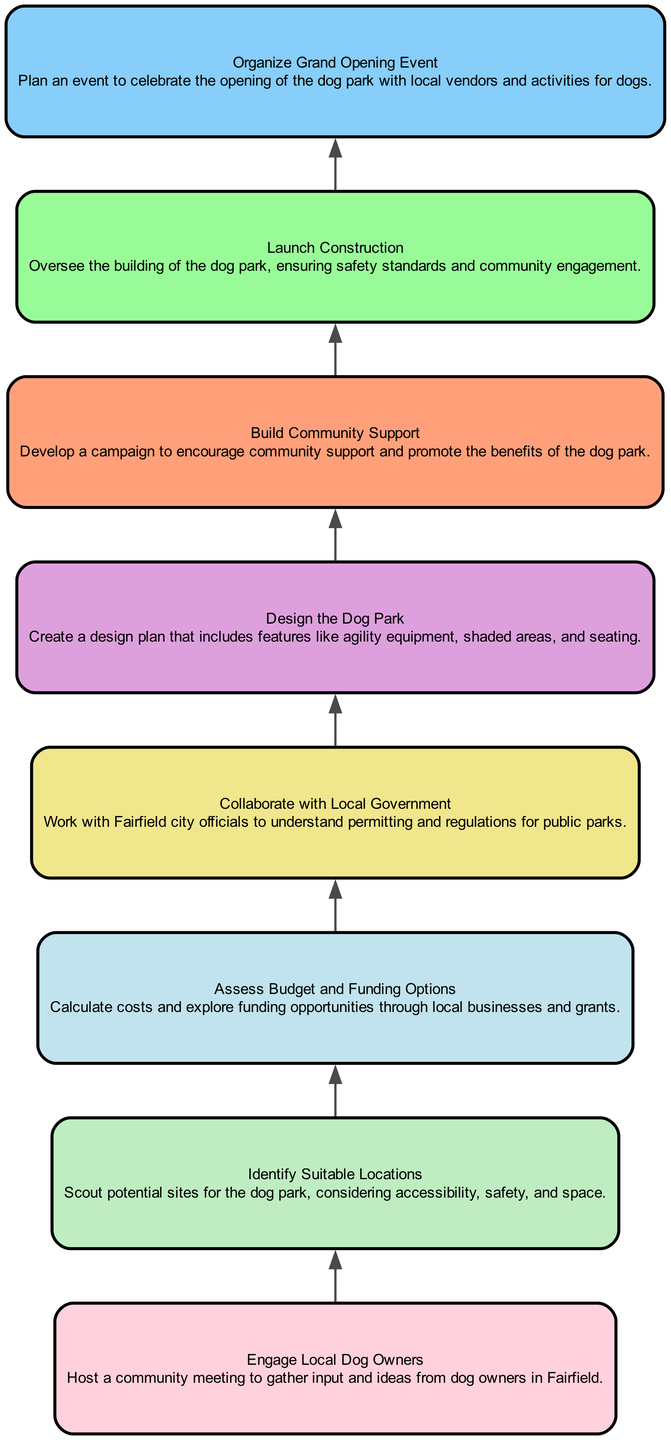What is the first step in the dog park planning process? The first step is labeled as "Engage Local Dog Owners." It is the initial node in the diagram and signifies the starting point of the planning process.
Answer: Engage Local Dog Owners How many total steps are there in the diagram? By counting the number of nodes in the diagram, there are eight distinct steps outlined for planning the dog park.
Answer: 8 What step comes immediately after "Assess Budget and Funding Options"? The step that follows "Assess Budget and Funding Options" is "Collaborate with Local Government." This relationship can be observed directly by looking at the arrows connecting these nodes.
Answer: Collaborate with Local Government Which step focuses on community engagement? The step dedicated to community engagement is "Build Community Support." It explicitly mentions developing a campaign to encourage community support, highlighting its importance in the planning process.
Answer: Build Community Support Which two steps are directly connected to "Design the Dog Park"? "Collaborate with Local Government" precedes it and "Launch Construction" follows it, thus these two steps are connected directly to "Design the Dog Park" in terms of the flow of the planning process.
Answer: Collaborate with Local Government, Launch Construction What is the final step in the planning process? The last step in the diagram is labeled as "Organize Grand Opening Event," making it the endpoint of the process for planning the dog park.
Answer: Organize Grand Opening Event Which step involves working with Fairfield city officials? The step that involves this action is "Collaborate with Local Government." This implies the necessity of understanding local regulations and permits required for public parks.
Answer: Collaborate with Local Government How does the first step relate to the rest of the steps in the process? The first step, "Engage Local Dog Owners," establishes the foundation for all subsequent actions by gathering input and ideas from the community, which is critical for successful planning and support.
Answer: It sets the foundation for the process 